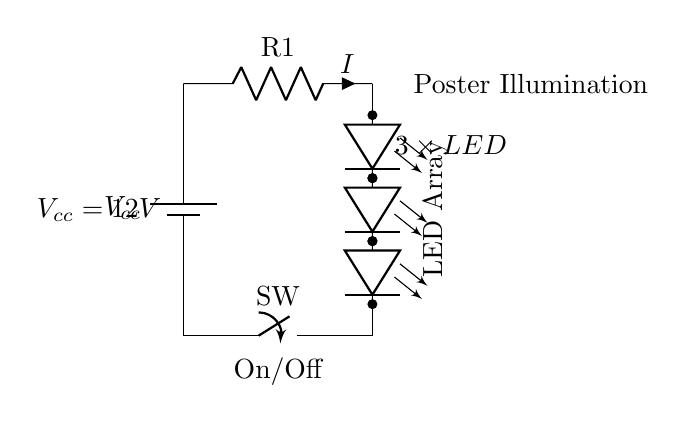What is the power supply voltage in this circuit? The power supply voltage, labeled as \(V_{cc}\), is shown in the circuit diagram and is specified as 12 volts.
Answer: 12 volts What type of components are used for poster illumination? The circuit shows an array of LEDs connected in series for poster illumination. This is indicated by the "LED Array" label in the diagram.
Answer: LED array How many LEDs are there in total? The circuit diagram clearly indicates that there are three LEDs connected in series, which is shown by the three separate LED symbols.
Answer: 3 LEDs What is the function of the switch in this circuit? The switch in the circuit is used to turn the circuit on and off. Its label "On/Off" shows its purpose, allowing control over the illumination of the poster.
Answer: On/Off What is the role of the resistor in the circuit? The resistor is labeled \(R1\) and is used for current limiting, which protects the LEDs from excessive current that could cause damage. This is implied by the current \(I\) flowing through it.
Answer: Current limiting If the voltage remains constant, what happens to the current when more LEDs are added to the circuit? Adding more LEDs in series will increase the total forward voltage drop, which will reduce the current flowing through the circuit, assuming the voltage supply stays the same. This is based on Ohm's law, where voltage, current, and resistance are interrelated.
Answer: Decreases What does the label "Poster Illumination" indicate? The label "Poster Illumination" indicates the purpose of the LED array, which is specifically designed to illuminate movie posters, enhancing visibility and display.
Answer: Purpose of illumination 